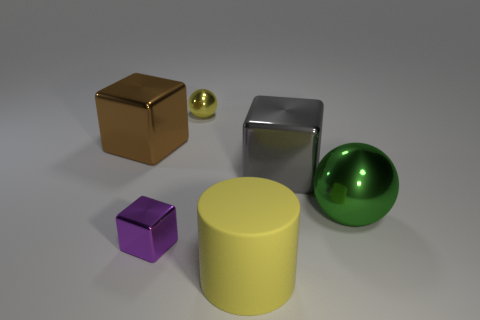Subtract all gray cubes. How many cubes are left? 2 Subtract all brown cubes. How many cubes are left? 2 Add 3 gray metal cylinders. How many objects exist? 9 Subtract 1 balls. How many balls are left? 1 Subtract all cylinders. How many objects are left? 5 Subtract all red cubes. Subtract all gray balls. How many cubes are left? 3 Subtract all big brown objects. Subtract all yellow balls. How many objects are left? 4 Add 6 large gray blocks. How many large gray blocks are left? 7 Add 5 big metallic things. How many big metallic things exist? 8 Subtract 0 blue cylinders. How many objects are left? 6 